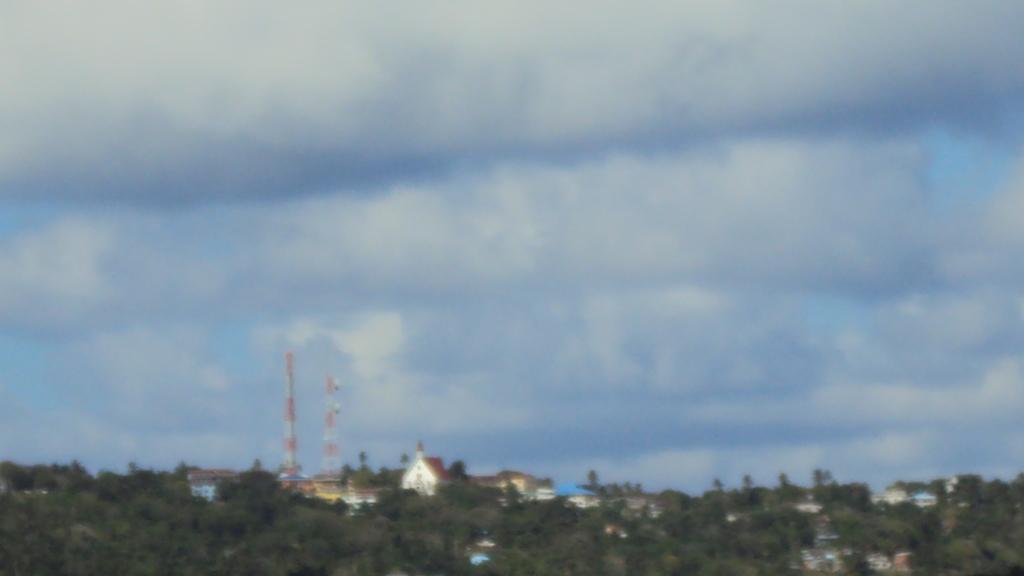What type of natural elements can be seen in the background of the image? There are trees in the background of the image. What type of man-made structures are visible in the background of the image? There are houses and towers in the background of the image. What is the condition of the sky in the background of the image? The sky is cloudy in the background of the image. What type of manager is responsible for the credit in the image? There is no manager or credit present in the image; it features trees, houses, towers, and a cloudy sky. What season is depicted in the image? The provided facts do not mention any specific season, so it cannot be determined from the image. 